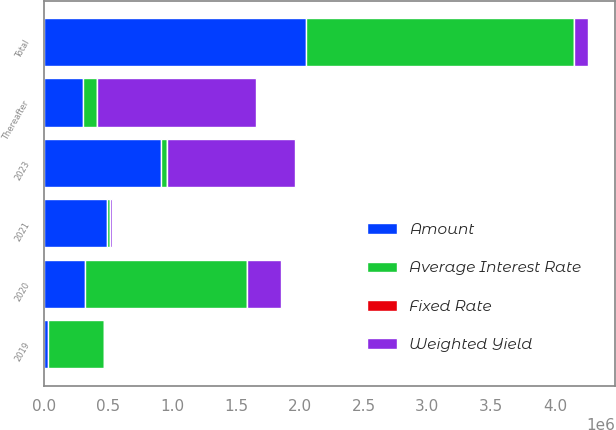Convert chart to OTSL. <chart><loc_0><loc_0><loc_500><loc_500><stacked_bar_chart><ecel><fcel>2019<fcel>2020<fcel>2021<fcel>2023<fcel>Thereafter<fcel>Total<nl><fcel>Weighted Yield<fcel>6241<fcel>261117<fcel>11636<fcel>1.0073e+06<fcel>1.2454e+06<fcel>109190<nl><fcel>Fixed Rate<fcel>4.08<fcel>3.87<fcel>3.83<fcel>4.08<fcel>4.29<fcel>3.92<nl><fcel>Amount<fcel>27500<fcel>315523<fcel>489869<fcel>915550<fcel>300000<fcel>2.04844e+06<nl><fcel>Average Interest Rate<fcel>442557<fcel>1.27368e+06<fcel>26471<fcel>42706<fcel>109190<fcel>2.09939e+06<nl></chart> 